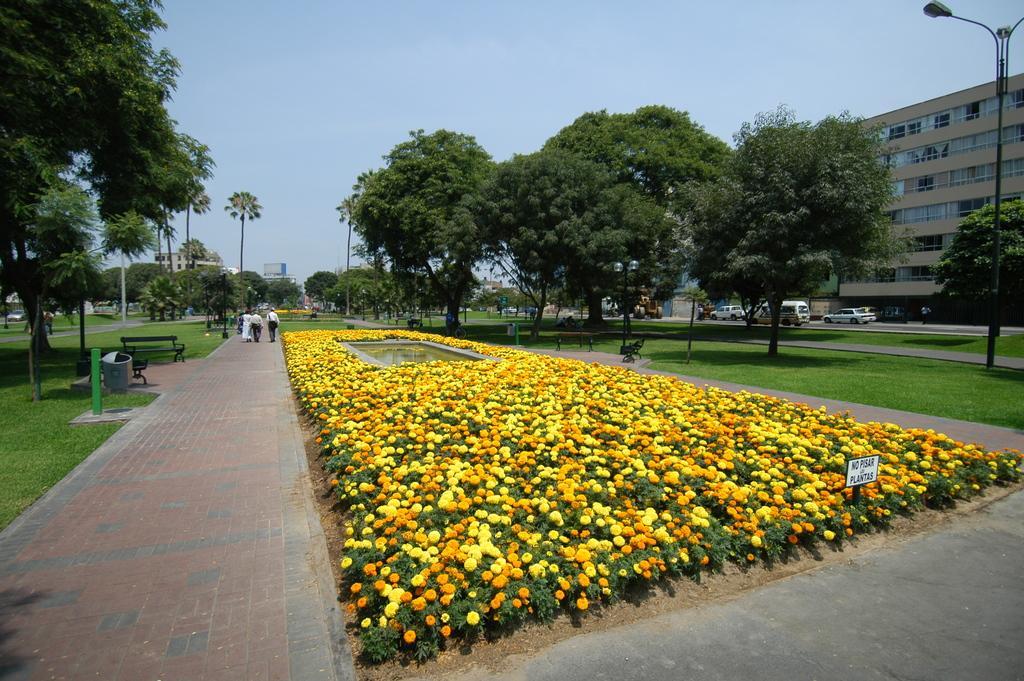In one or two sentences, can you explain what this image depicts? In the picture we can see a path near it we can see a path with full of plants and flowers to it which are yellow and orange in color and in the middle of it we can see water and on the path we can see some people are walking and beside them we can see grass surface, trees and bench on it and on the other side we can see a grass surface with some trees and behind it we can see a building and near it we can see a car and in the background we can see a sky. 